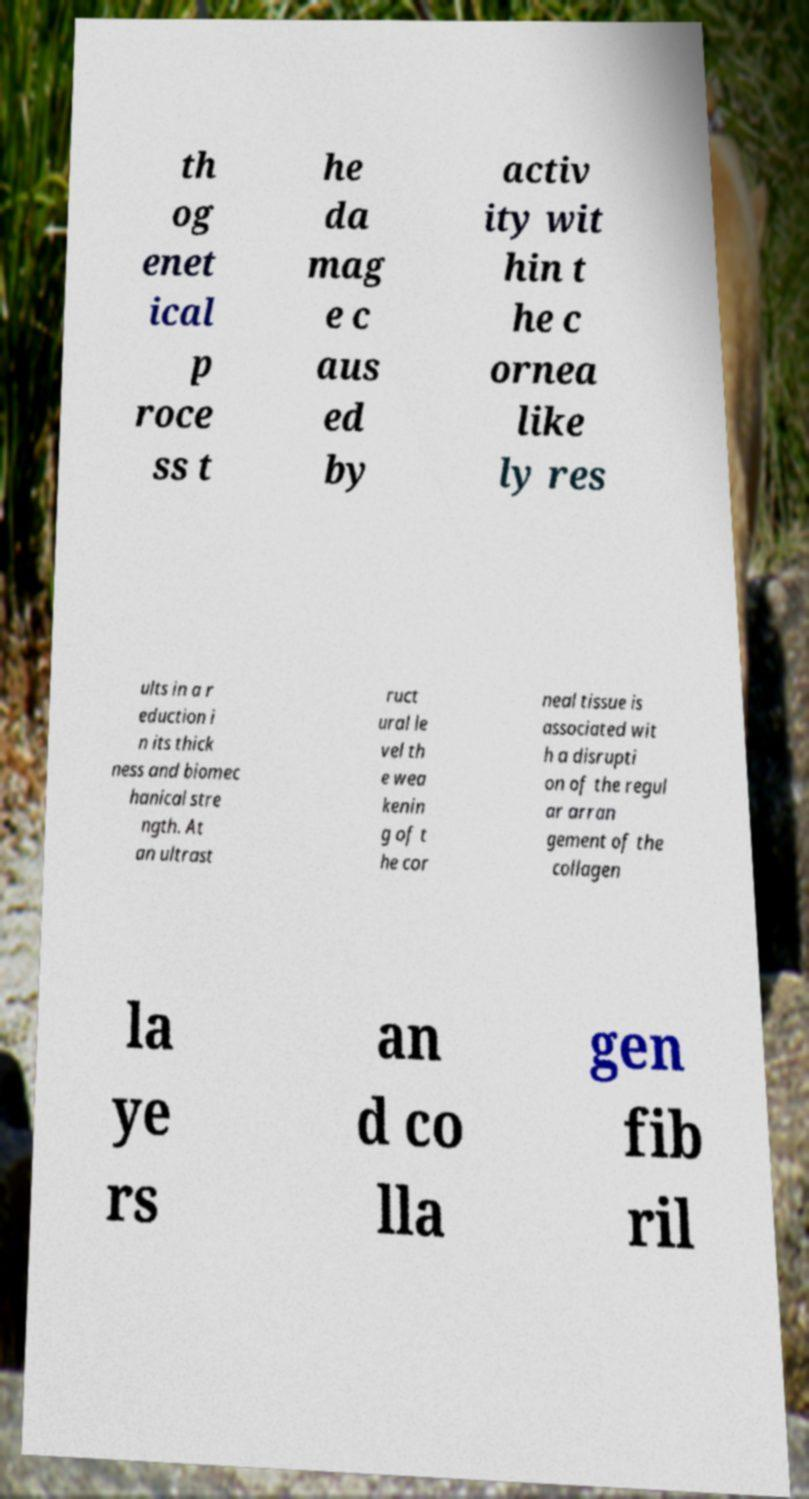Could you assist in decoding the text presented in this image and type it out clearly? th og enet ical p roce ss t he da mag e c aus ed by activ ity wit hin t he c ornea like ly res ults in a r eduction i n its thick ness and biomec hanical stre ngth. At an ultrast ruct ural le vel th e wea kenin g of t he cor neal tissue is associated wit h a disrupti on of the regul ar arran gement of the collagen la ye rs an d co lla gen fib ril 